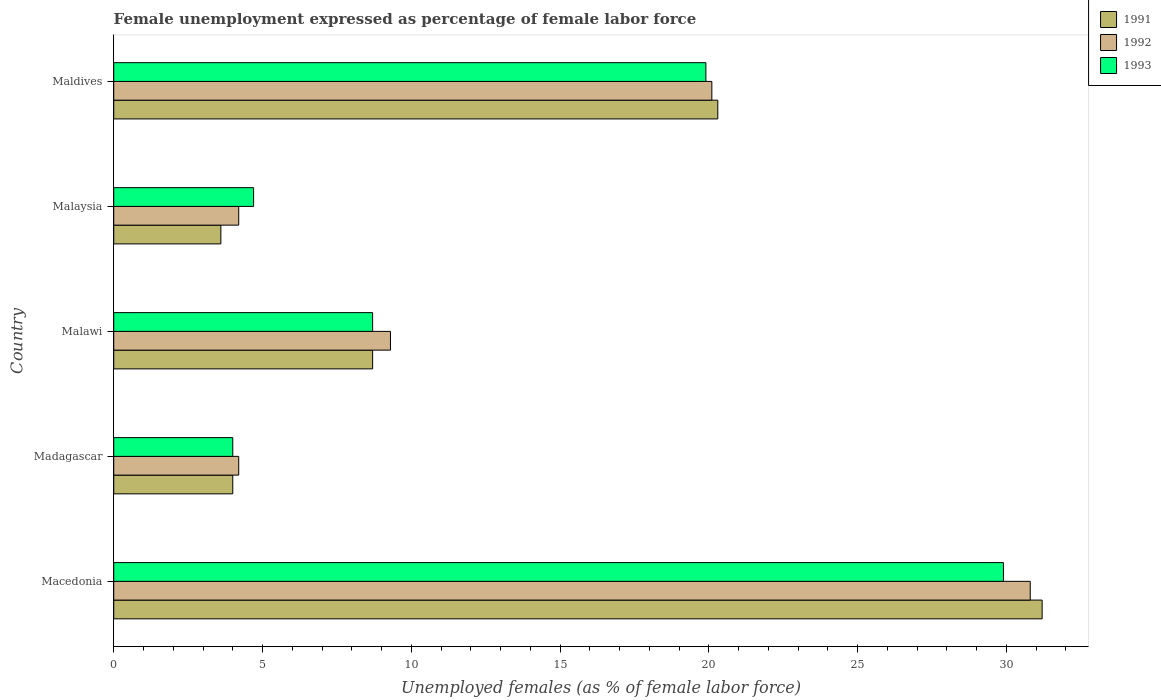Are the number of bars per tick equal to the number of legend labels?
Make the answer very short. Yes. Are the number of bars on each tick of the Y-axis equal?
Your response must be concise. Yes. How many bars are there on the 2nd tick from the top?
Give a very brief answer. 3. How many bars are there on the 3rd tick from the bottom?
Your answer should be very brief. 3. What is the label of the 2nd group of bars from the top?
Your answer should be compact. Malaysia. In how many cases, is the number of bars for a given country not equal to the number of legend labels?
Provide a succinct answer. 0. What is the unemployment in females in in 1992 in Malaysia?
Make the answer very short. 4.2. Across all countries, what is the maximum unemployment in females in in 1992?
Offer a terse response. 30.8. Across all countries, what is the minimum unemployment in females in in 1992?
Provide a short and direct response. 4.2. In which country was the unemployment in females in in 1993 maximum?
Provide a short and direct response. Macedonia. In which country was the unemployment in females in in 1992 minimum?
Give a very brief answer. Madagascar. What is the total unemployment in females in in 1991 in the graph?
Offer a very short reply. 67.8. What is the difference between the unemployment in females in in 1991 in Macedonia and that in Maldives?
Ensure brevity in your answer.  10.9. What is the difference between the unemployment in females in in 1993 in Maldives and the unemployment in females in in 1992 in Macedonia?
Offer a terse response. -10.9. What is the average unemployment in females in in 1993 per country?
Ensure brevity in your answer.  13.44. What is the difference between the unemployment in females in in 1991 and unemployment in females in in 1992 in Malawi?
Offer a very short reply. -0.6. In how many countries, is the unemployment in females in in 1991 greater than 12 %?
Your answer should be compact. 2. What is the ratio of the unemployment in females in in 1991 in Macedonia to that in Madagascar?
Keep it short and to the point. 7.8. Is the difference between the unemployment in females in in 1991 in Madagascar and Maldives greater than the difference between the unemployment in females in in 1992 in Madagascar and Maldives?
Make the answer very short. No. What is the difference between the highest and the second highest unemployment in females in in 1992?
Provide a short and direct response. 10.7. What is the difference between the highest and the lowest unemployment in females in in 1991?
Keep it short and to the point. 27.6. Is the sum of the unemployment in females in in 1992 in Madagascar and Maldives greater than the maximum unemployment in females in in 1991 across all countries?
Your response must be concise. No. What does the 1st bar from the bottom in Maldives represents?
Offer a very short reply. 1991. Is it the case that in every country, the sum of the unemployment in females in in 1993 and unemployment in females in in 1992 is greater than the unemployment in females in in 1991?
Your answer should be very brief. Yes. How many bars are there?
Provide a short and direct response. 15. How many countries are there in the graph?
Offer a very short reply. 5. What is the difference between two consecutive major ticks on the X-axis?
Your answer should be very brief. 5. Are the values on the major ticks of X-axis written in scientific E-notation?
Offer a very short reply. No. Does the graph contain any zero values?
Make the answer very short. No. Does the graph contain grids?
Ensure brevity in your answer.  No. Where does the legend appear in the graph?
Your answer should be compact. Top right. How are the legend labels stacked?
Provide a short and direct response. Vertical. What is the title of the graph?
Your answer should be compact. Female unemployment expressed as percentage of female labor force. Does "2012" appear as one of the legend labels in the graph?
Provide a succinct answer. No. What is the label or title of the X-axis?
Your answer should be compact. Unemployed females (as % of female labor force). What is the label or title of the Y-axis?
Ensure brevity in your answer.  Country. What is the Unemployed females (as % of female labor force) in 1991 in Macedonia?
Your answer should be very brief. 31.2. What is the Unemployed females (as % of female labor force) in 1992 in Macedonia?
Your response must be concise. 30.8. What is the Unemployed females (as % of female labor force) in 1993 in Macedonia?
Offer a terse response. 29.9. What is the Unemployed females (as % of female labor force) of 1991 in Madagascar?
Make the answer very short. 4. What is the Unemployed females (as % of female labor force) in 1992 in Madagascar?
Make the answer very short. 4.2. What is the Unemployed females (as % of female labor force) of 1991 in Malawi?
Your answer should be very brief. 8.7. What is the Unemployed females (as % of female labor force) of 1992 in Malawi?
Keep it short and to the point. 9.3. What is the Unemployed females (as % of female labor force) of 1993 in Malawi?
Your response must be concise. 8.7. What is the Unemployed females (as % of female labor force) of 1991 in Malaysia?
Provide a succinct answer. 3.6. What is the Unemployed females (as % of female labor force) in 1992 in Malaysia?
Keep it short and to the point. 4.2. What is the Unemployed females (as % of female labor force) in 1993 in Malaysia?
Your response must be concise. 4.7. What is the Unemployed females (as % of female labor force) of 1991 in Maldives?
Your answer should be very brief. 20.3. What is the Unemployed females (as % of female labor force) of 1992 in Maldives?
Ensure brevity in your answer.  20.1. What is the Unemployed females (as % of female labor force) of 1993 in Maldives?
Offer a very short reply. 19.9. Across all countries, what is the maximum Unemployed females (as % of female labor force) of 1991?
Your answer should be very brief. 31.2. Across all countries, what is the maximum Unemployed females (as % of female labor force) of 1992?
Keep it short and to the point. 30.8. Across all countries, what is the maximum Unemployed females (as % of female labor force) in 1993?
Ensure brevity in your answer.  29.9. Across all countries, what is the minimum Unemployed females (as % of female labor force) of 1991?
Your answer should be compact. 3.6. Across all countries, what is the minimum Unemployed females (as % of female labor force) in 1992?
Your response must be concise. 4.2. Across all countries, what is the minimum Unemployed females (as % of female labor force) of 1993?
Give a very brief answer. 4. What is the total Unemployed females (as % of female labor force) of 1991 in the graph?
Provide a succinct answer. 67.8. What is the total Unemployed females (as % of female labor force) of 1992 in the graph?
Your response must be concise. 68.6. What is the total Unemployed females (as % of female labor force) in 1993 in the graph?
Provide a short and direct response. 67.2. What is the difference between the Unemployed females (as % of female labor force) of 1991 in Macedonia and that in Madagascar?
Provide a short and direct response. 27.2. What is the difference between the Unemployed females (as % of female labor force) of 1992 in Macedonia and that in Madagascar?
Offer a very short reply. 26.6. What is the difference between the Unemployed females (as % of female labor force) in 1993 in Macedonia and that in Madagascar?
Provide a short and direct response. 25.9. What is the difference between the Unemployed females (as % of female labor force) of 1991 in Macedonia and that in Malawi?
Provide a short and direct response. 22.5. What is the difference between the Unemployed females (as % of female labor force) of 1992 in Macedonia and that in Malawi?
Provide a short and direct response. 21.5. What is the difference between the Unemployed females (as % of female labor force) in 1993 in Macedonia and that in Malawi?
Give a very brief answer. 21.2. What is the difference between the Unemployed females (as % of female labor force) in 1991 in Macedonia and that in Malaysia?
Ensure brevity in your answer.  27.6. What is the difference between the Unemployed females (as % of female labor force) of 1992 in Macedonia and that in Malaysia?
Offer a terse response. 26.6. What is the difference between the Unemployed females (as % of female labor force) in 1993 in Macedonia and that in Malaysia?
Provide a short and direct response. 25.2. What is the difference between the Unemployed females (as % of female labor force) of 1991 in Macedonia and that in Maldives?
Provide a succinct answer. 10.9. What is the difference between the Unemployed females (as % of female labor force) in 1993 in Macedonia and that in Maldives?
Offer a terse response. 10. What is the difference between the Unemployed females (as % of female labor force) in 1991 in Madagascar and that in Malawi?
Offer a terse response. -4.7. What is the difference between the Unemployed females (as % of female labor force) of 1992 in Madagascar and that in Malawi?
Your answer should be compact. -5.1. What is the difference between the Unemployed females (as % of female labor force) in 1993 in Madagascar and that in Malawi?
Your answer should be compact. -4.7. What is the difference between the Unemployed females (as % of female labor force) in 1991 in Madagascar and that in Malaysia?
Your answer should be compact. 0.4. What is the difference between the Unemployed females (as % of female labor force) of 1991 in Madagascar and that in Maldives?
Keep it short and to the point. -16.3. What is the difference between the Unemployed females (as % of female labor force) in 1992 in Madagascar and that in Maldives?
Ensure brevity in your answer.  -15.9. What is the difference between the Unemployed females (as % of female labor force) in 1993 in Madagascar and that in Maldives?
Make the answer very short. -15.9. What is the difference between the Unemployed females (as % of female labor force) in 1991 in Malawi and that in Malaysia?
Give a very brief answer. 5.1. What is the difference between the Unemployed females (as % of female labor force) in 1993 in Malawi and that in Malaysia?
Provide a succinct answer. 4. What is the difference between the Unemployed females (as % of female labor force) of 1991 in Malawi and that in Maldives?
Offer a terse response. -11.6. What is the difference between the Unemployed females (as % of female labor force) of 1991 in Malaysia and that in Maldives?
Your response must be concise. -16.7. What is the difference between the Unemployed females (as % of female labor force) in 1992 in Malaysia and that in Maldives?
Your answer should be very brief. -15.9. What is the difference between the Unemployed females (as % of female labor force) of 1993 in Malaysia and that in Maldives?
Offer a terse response. -15.2. What is the difference between the Unemployed females (as % of female labor force) of 1991 in Macedonia and the Unemployed females (as % of female labor force) of 1993 in Madagascar?
Provide a short and direct response. 27.2. What is the difference between the Unemployed females (as % of female labor force) in 1992 in Macedonia and the Unemployed females (as % of female labor force) in 1993 in Madagascar?
Ensure brevity in your answer.  26.8. What is the difference between the Unemployed females (as % of female labor force) in 1991 in Macedonia and the Unemployed females (as % of female labor force) in 1992 in Malawi?
Your answer should be very brief. 21.9. What is the difference between the Unemployed females (as % of female labor force) in 1992 in Macedonia and the Unemployed females (as % of female labor force) in 1993 in Malawi?
Your answer should be very brief. 22.1. What is the difference between the Unemployed females (as % of female labor force) of 1991 in Macedonia and the Unemployed females (as % of female labor force) of 1992 in Malaysia?
Give a very brief answer. 27. What is the difference between the Unemployed females (as % of female labor force) of 1991 in Macedonia and the Unemployed females (as % of female labor force) of 1993 in Malaysia?
Keep it short and to the point. 26.5. What is the difference between the Unemployed females (as % of female labor force) in 1992 in Macedonia and the Unemployed females (as % of female labor force) in 1993 in Malaysia?
Provide a short and direct response. 26.1. What is the difference between the Unemployed females (as % of female labor force) in 1991 in Macedonia and the Unemployed females (as % of female labor force) in 1992 in Maldives?
Provide a short and direct response. 11.1. What is the difference between the Unemployed females (as % of female labor force) in 1991 in Madagascar and the Unemployed females (as % of female labor force) in 1992 in Malawi?
Offer a very short reply. -5.3. What is the difference between the Unemployed females (as % of female labor force) of 1991 in Madagascar and the Unemployed females (as % of female labor force) of 1993 in Malaysia?
Provide a succinct answer. -0.7. What is the difference between the Unemployed females (as % of female labor force) in 1992 in Madagascar and the Unemployed females (as % of female labor force) in 1993 in Malaysia?
Your response must be concise. -0.5. What is the difference between the Unemployed females (as % of female labor force) of 1991 in Madagascar and the Unemployed females (as % of female labor force) of 1992 in Maldives?
Offer a terse response. -16.1. What is the difference between the Unemployed females (as % of female labor force) in 1991 in Madagascar and the Unemployed females (as % of female labor force) in 1993 in Maldives?
Offer a very short reply. -15.9. What is the difference between the Unemployed females (as % of female labor force) in 1992 in Madagascar and the Unemployed females (as % of female labor force) in 1993 in Maldives?
Your answer should be very brief. -15.7. What is the difference between the Unemployed females (as % of female labor force) of 1992 in Malawi and the Unemployed females (as % of female labor force) of 1993 in Malaysia?
Your response must be concise. 4.6. What is the difference between the Unemployed females (as % of female labor force) of 1991 in Malaysia and the Unemployed females (as % of female labor force) of 1992 in Maldives?
Make the answer very short. -16.5. What is the difference between the Unemployed females (as % of female labor force) in 1991 in Malaysia and the Unemployed females (as % of female labor force) in 1993 in Maldives?
Ensure brevity in your answer.  -16.3. What is the difference between the Unemployed females (as % of female labor force) in 1992 in Malaysia and the Unemployed females (as % of female labor force) in 1993 in Maldives?
Offer a terse response. -15.7. What is the average Unemployed females (as % of female labor force) of 1991 per country?
Your answer should be very brief. 13.56. What is the average Unemployed females (as % of female labor force) of 1992 per country?
Provide a short and direct response. 13.72. What is the average Unemployed females (as % of female labor force) in 1993 per country?
Make the answer very short. 13.44. What is the difference between the Unemployed females (as % of female labor force) in 1991 and Unemployed females (as % of female labor force) in 1993 in Macedonia?
Your response must be concise. 1.3. What is the difference between the Unemployed females (as % of female labor force) in 1991 and Unemployed females (as % of female labor force) in 1992 in Madagascar?
Your answer should be very brief. -0.2. What is the difference between the Unemployed females (as % of female labor force) in 1991 and Unemployed females (as % of female labor force) in 1993 in Madagascar?
Provide a succinct answer. 0. What is the difference between the Unemployed females (as % of female labor force) in 1992 and Unemployed females (as % of female labor force) in 1993 in Madagascar?
Keep it short and to the point. 0.2. What is the difference between the Unemployed females (as % of female labor force) in 1991 and Unemployed females (as % of female labor force) in 1992 in Malawi?
Provide a succinct answer. -0.6. What is the difference between the Unemployed females (as % of female labor force) of 1991 and Unemployed females (as % of female labor force) of 1993 in Malawi?
Provide a short and direct response. 0. What is the difference between the Unemployed females (as % of female labor force) of 1991 and Unemployed females (as % of female labor force) of 1992 in Malaysia?
Your response must be concise. -0.6. What is the difference between the Unemployed females (as % of female labor force) of 1992 and Unemployed females (as % of female labor force) of 1993 in Malaysia?
Keep it short and to the point. -0.5. What is the difference between the Unemployed females (as % of female labor force) of 1991 and Unemployed females (as % of female labor force) of 1992 in Maldives?
Provide a short and direct response. 0.2. What is the ratio of the Unemployed females (as % of female labor force) in 1991 in Macedonia to that in Madagascar?
Offer a terse response. 7.8. What is the ratio of the Unemployed females (as % of female labor force) in 1992 in Macedonia to that in Madagascar?
Offer a very short reply. 7.33. What is the ratio of the Unemployed females (as % of female labor force) of 1993 in Macedonia to that in Madagascar?
Your answer should be compact. 7.47. What is the ratio of the Unemployed females (as % of female labor force) in 1991 in Macedonia to that in Malawi?
Your answer should be compact. 3.59. What is the ratio of the Unemployed females (as % of female labor force) in 1992 in Macedonia to that in Malawi?
Make the answer very short. 3.31. What is the ratio of the Unemployed females (as % of female labor force) of 1993 in Macedonia to that in Malawi?
Provide a short and direct response. 3.44. What is the ratio of the Unemployed females (as % of female labor force) in 1991 in Macedonia to that in Malaysia?
Offer a very short reply. 8.67. What is the ratio of the Unemployed females (as % of female labor force) in 1992 in Macedonia to that in Malaysia?
Your response must be concise. 7.33. What is the ratio of the Unemployed females (as % of female labor force) of 1993 in Macedonia to that in Malaysia?
Your answer should be very brief. 6.36. What is the ratio of the Unemployed females (as % of female labor force) in 1991 in Macedonia to that in Maldives?
Keep it short and to the point. 1.54. What is the ratio of the Unemployed females (as % of female labor force) of 1992 in Macedonia to that in Maldives?
Your answer should be very brief. 1.53. What is the ratio of the Unemployed females (as % of female labor force) of 1993 in Macedonia to that in Maldives?
Your answer should be compact. 1.5. What is the ratio of the Unemployed females (as % of female labor force) in 1991 in Madagascar to that in Malawi?
Your response must be concise. 0.46. What is the ratio of the Unemployed females (as % of female labor force) of 1992 in Madagascar to that in Malawi?
Ensure brevity in your answer.  0.45. What is the ratio of the Unemployed females (as % of female labor force) in 1993 in Madagascar to that in Malawi?
Provide a short and direct response. 0.46. What is the ratio of the Unemployed females (as % of female labor force) in 1991 in Madagascar to that in Malaysia?
Offer a terse response. 1.11. What is the ratio of the Unemployed females (as % of female labor force) in 1992 in Madagascar to that in Malaysia?
Give a very brief answer. 1. What is the ratio of the Unemployed females (as % of female labor force) of 1993 in Madagascar to that in Malaysia?
Provide a short and direct response. 0.85. What is the ratio of the Unemployed females (as % of female labor force) of 1991 in Madagascar to that in Maldives?
Ensure brevity in your answer.  0.2. What is the ratio of the Unemployed females (as % of female labor force) of 1992 in Madagascar to that in Maldives?
Provide a short and direct response. 0.21. What is the ratio of the Unemployed females (as % of female labor force) in 1993 in Madagascar to that in Maldives?
Keep it short and to the point. 0.2. What is the ratio of the Unemployed females (as % of female labor force) in 1991 in Malawi to that in Malaysia?
Provide a succinct answer. 2.42. What is the ratio of the Unemployed females (as % of female labor force) of 1992 in Malawi to that in Malaysia?
Keep it short and to the point. 2.21. What is the ratio of the Unemployed females (as % of female labor force) of 1993 in Malawi to that in Malaysia?
Your answer should be very brief. 1.85. What is the ratio of the Unemployed females (as % of female labor force) of 1991 in Malawi to that in Maldives?
Make the answer very short. 0.43. What is the ratio of the Unemployed females (as % of female labor force) of 1992 in Malawi to that in Maldives?
Your answer should be compact. 0.46. What is the ratio of the Unemployed females (as % of female labor force) in 1993 in Malawi to that in Maldives?
Keep it short and to the point. 0.44. What is the ratio of the Unemployed females (as % of female labor force) in 1991 in Malaysia to that in Maldives?
Give a very brief answer. 0.18. What is the ratio of the Unemployed females (as % of female labor force) of 1992 in Malaysia to that in Maldives?
Give a very brief answer. 0.21. What is the ratio of the Unemployed females (as % of female labor force) of 1993 in Malaysia to that in Maldives?
Make the answer very short. 0.24. What is the difference between the highest and the lowest Unemployed females (as % of female labor force) in 1991?
Keep it short and to the point. 27.6. What is the difference between the highest and the lowest Unemployed females (as % of female labor force) of 1992?
Make the answer very short. 26.6. What is the difference between the highest and the lowest Unemployed females (as % of female labor force) in 1993?
Give a very brief answer. 25.9. 